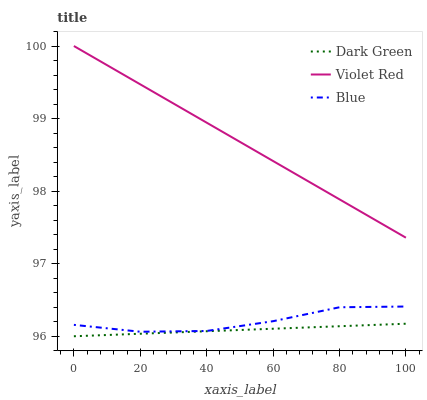Does Dark Green have the minimum area under the curve?
Answer yes or no. Yes. Does Violet Red have the maximum area under the curve?
Answer yes or no. Yes. Does Violet Red have the minimum area under the curve?
Answer yes or no. No. Does Dark Green have the maximum area under the curve?
Answer yes or no. No. Is Dark Green the smoothest?
Answer yes or no. Yes. Is Blue the roughest?
Answer yes or no. Yes. Is Violet Red the smoothest?
Answer yes or no. No. Is Violet Red the roughest?
Answer yes or no. No. Does Dark Green have the lowest value?
Answer yes or no. Yes. Does Violet Red have the lowest value?
Answer yes or no. No. Does Violet Red have the highest value?
Answer yes or no. Yes. Does Dark Green have the highest value?
Answer yes or no. No. Is Dark Green less than Blue?
Answer yes or no. Yes. Is Blue greater than Dark Green?
Answer yes or no. Yes. Does Dark Green intersect Blue?
Answer yes or no. No. 